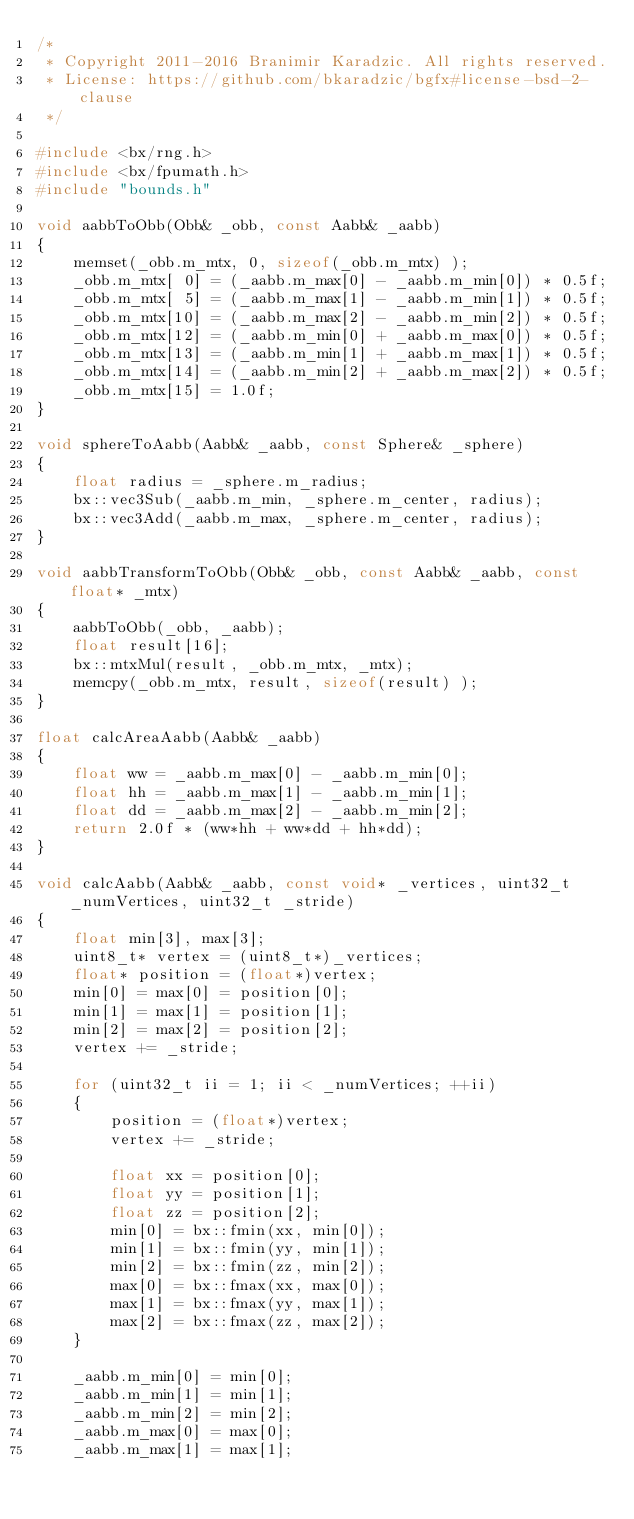<code> <loc_0><loc_0><loc_500><loc_500><_C++_>/*
 * Copyright 2011-2016 Branimir Karadzic. All rights reserved.
 * License: https://github.com/bkaradzic/bgfx#license-bsd-2-clause
 */

#include <bx/rng.h>
#include <bx/fpumath.h>
#include "bounds.h"

void aabbToObb(Obb& _obb, const Aabb& _aabb)
{
	memset(_obb.m_mtx, 0, sizeof(_obb.m_mtx) );
	_obb.m_mtx[ 0] = (_aabb.m_max[0] - _aabb.m_min[0]) * 0.5f;
	_obb.m_mtx[ 5] = (_aabb.m_max[1] - _aabb.m_min[1]) * 0.5f;
	_obb.m_mtx[10] = (_aabb.m_max[2] - _aabb.m_min[2]) * 0.5f;
	_obb.m_mtx[12] = (_aabb.m_min[0] + _aabb.m_max[0]) * 0.5f;
	_obb.m_mtx[13] = (_aabb.m_min[1] + _aabb.m_max[1]) * 0.5f;
	_obb.m_mtx[14] = (_aabb.m_min[2] + _aabb.m_max[2]) * 0.5f;
	_obb.m_mtx[15] = 1.0f;
}

void sphereToAabb(Aabb& _aabb, const Sphere& _sphere)
{
	float radius = _sphere.m_radius;
	bx::vec3Sub(_aabb.m_min, _sphere.m_center, radius);
	bx::vec3Add(_aabb.m_max, _sphere.m_center, radius);
}

void aabbTransformToObb(Obb& _obb, const Aabb& _aabb, const float* _mtx)
{
	aabbToObb(_obb, _aabb);
	float result[16];
	bx::mtxMul(result, _obb.m_mtx, _mtx);
	memcpy(_obb.m_mtx, result, sizeof(result) );
}

float calcAreaAabb(Aabb& _aabb)
{
	float ww = _aabb.m_max[0] - _aabb.m_min[0];
	float hh = _aabb.m_max[1] - _aabb.m_min[1];
	float dd = _aabb.m_max[2] - _aabb.m_min[2];
	return 2.0f * (ww*hh + ww*dd + hh*dd);
}

void calcAabb(Aabb& _aabb, const void* _vertices, uint32_t _numVertices, uint32_t _stride)
{
	float min[3], max[3];
	uint8_t* vertex = (uint8_t*)_vertices;
	float* position = (float*)vertex;
	min[0] = max[0] = position[0];
	min[1] = max[1] = position[1];
	min[2] = max[2] = position[2];
	vertex += _stride;

	for (uint32_t ii = 1; ii < _numVertices; ++ii)
	{
		position = (float*)vertex;
		vertex += _stride;

		float xx = position[0];
		float yy = position[1];
		float zz = position[2];
		min[0] = bx::fmin(xx, min[0]);
		min[1] = bx::fmin(yy, min[1]);
		min[2] = bx::fmin(zz, min[2]);
		max[0] = bx::fmax(xx, max[0]);
		max[1] = bx::fmax(yy, max[1]);
		max[2] = bx::fmax(zz, max[2]);
	}

	_aabb.m_min[0] = min[0];
	_aabb.m_min[1] = min[1];
	_aabb.m_min[2] = min[2];
	_aabb.m_max[0] = max[0];
	_aabb.m_max[1] = max[1];</code> 